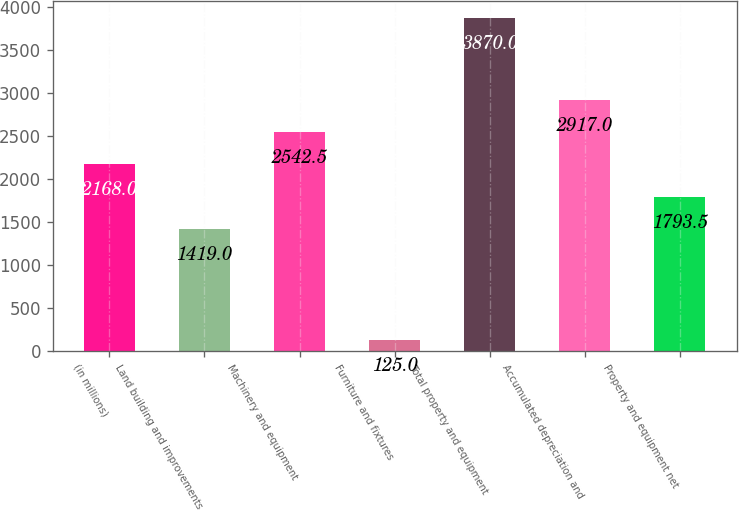Convert chart. <chart><loc_0><loc_0><loc_500><loc_500><bar_chart><fcel>(in millions)<fcel>Land building and improvements<fcel>Machinery and equipment<fcel>Furniture and fixtures<fcel>Total property and equipment<fcel>Accumulated depreciation and<fcel>Property and equipment net<nl><fcel>2168<fcel>1419<fcel>2542.5<fcel>125<fcel>3870<fcel>2917<fcel>1793.5<nl></chart> 